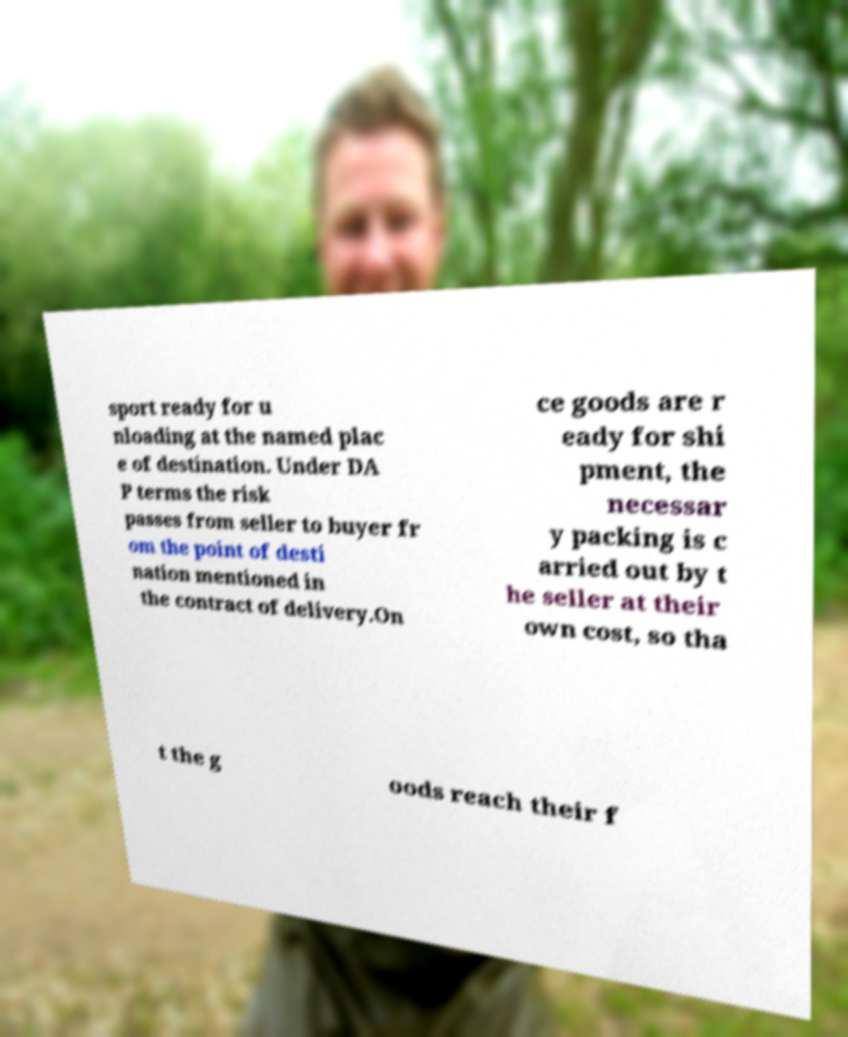Could you extract and type out the text from this image? sport ready for u nloading at the named plac e of destination. Under DA P terms the risk passes from seller to buyer fr om the point of desti nation mentioned in the contract of delivery.On ce goods are r eady for shi pment, the necessar y packing is c arried out by t he seller at their own cost, so tha t the g oods reach their f 